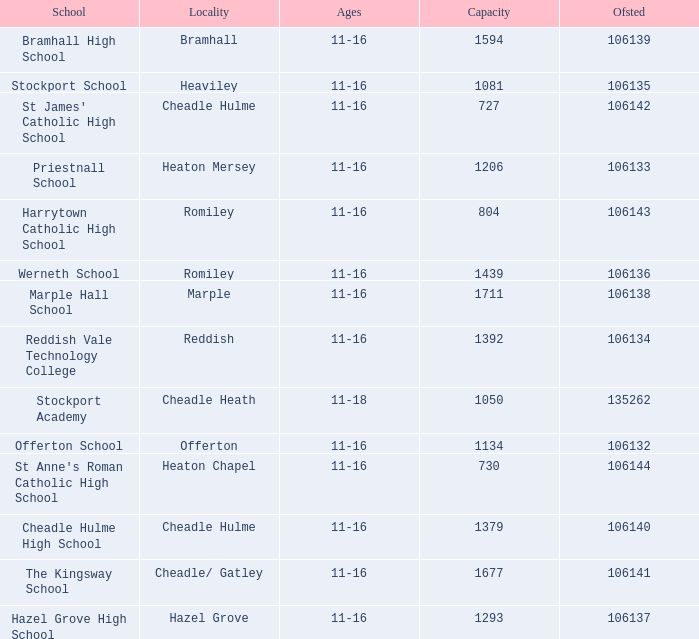Which School has Ages of 11-16, and an Ofsted smaller than 106142, and a Capacity of 1206? Priestnall School. 